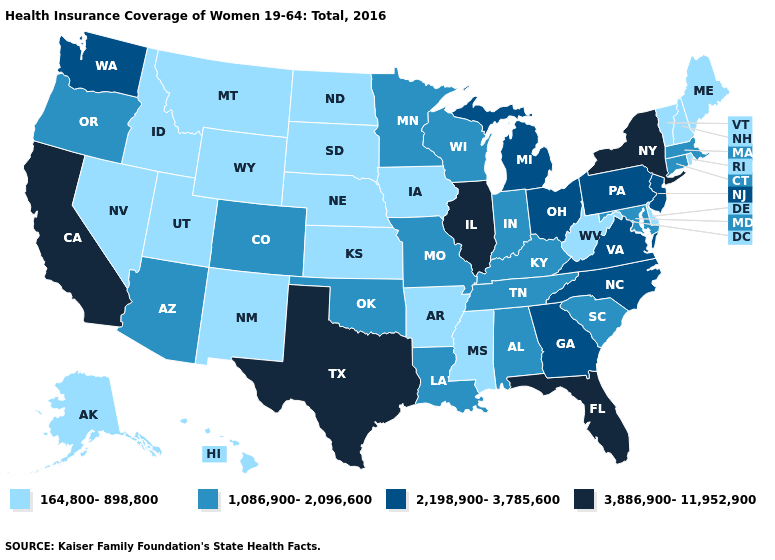Name the states that have a value in the range 1,086,900-2,096,600?
Answer briefly. Alabama, Arizona, Colorado, Connecticut, Indiana, Kentucky, Louisiana, Maryland, Massachusetts, Minnesota, Missouri, Oklahoma, Oregon, South Carolina, Tennessee, Wisconsin. Does Idaho have the same value as New York?
Concise answer only. No. What is the value of Vermont?
Answer briefly. 164,800-898,800. What is the highest value in the USA?
Answer briefly. 3,886,900-11,952,900. What is the highest value in states that border Florida?
Give a very brief answer. 2,198,900-3,785,600. What is the lowest value in the Northeast?
Concise answer only. 164,800-898,800. Among the states that border Massachusetts , does Rhode Island have the lowest value?
Keep it brief. Yes. Among the states that border Utah , which have the highest value?
Write a very short answer. Arizona, Colorado. Among the states that border Wyoming , does Colorado have the highest value?
Write a very short answer. Yes. Does Pennsylvania have the highest value in the Northeast?
Concise answer only. No. Which states hav the highest value in the West?
Be succinct. California. Does West Virginia have the lowest value in the South?
Short answer required. Yes. What is the value of Alabama?
Keep it brief. 1,086,900-2,096,600. Among the states that border Maine , which have the lowest value?
Keep it brief. New Hampshire. 